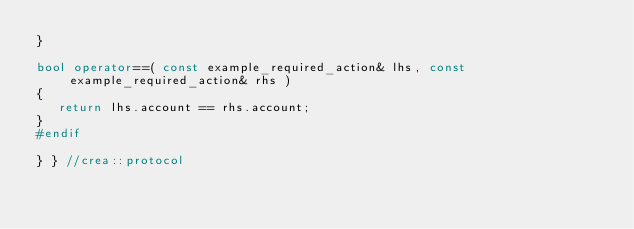Convert code to text. <code><loc_0><loc_0><loc_500><loc_500><_C++_>}

bool operator==( const example_required_action& lhs, const example_required_action& rhs )
{
   return lhs.account == rhs.account;
}
#endif

} } //crea::protocol
</code> 